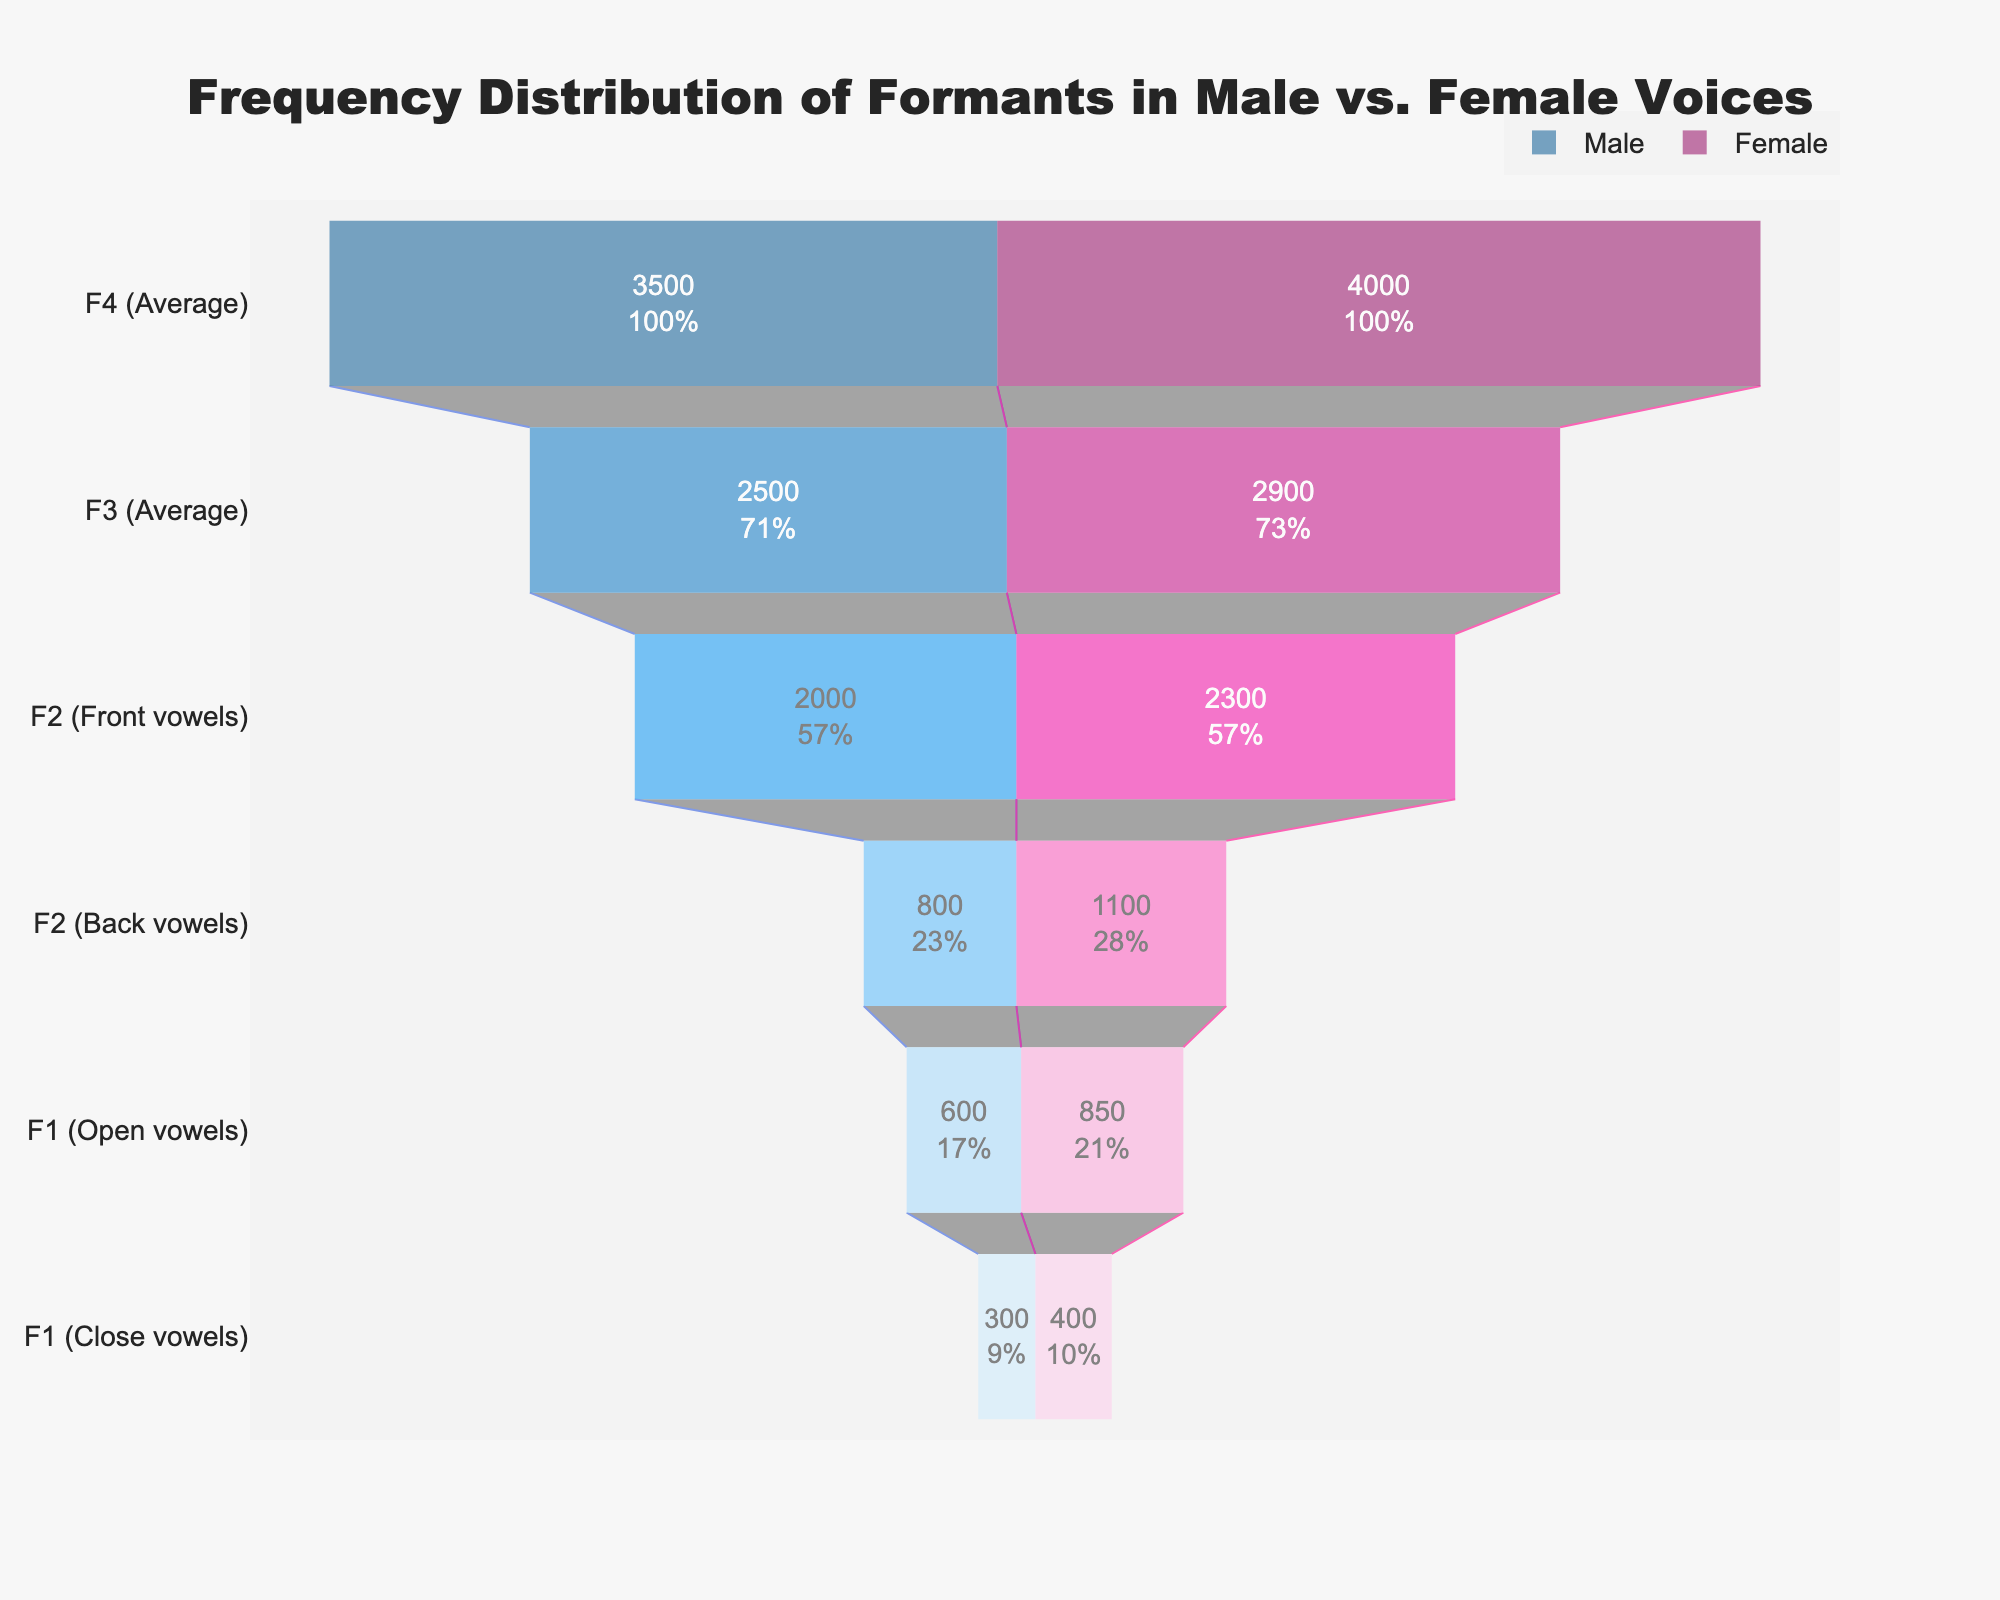What is the title of the funnel chart? The title of the funnel chart is displayed at the top center of the plot. It reads "Frequency Distribution of Formants in Male vs. Female Voices."
Answer: Frequency Distribution of Formants in Male vs. Female Voices What are the formants with the highest frequency for male and female voices, respectively? By examining the chart, the largest sections (highest frequencies) are at the top. For both male and female voices, the formants with the highest frequency are F4 (Average) with values 3500 Hz for males and 4000 Hz for females.
Answer: F4 (Average) for both Which formant shows the smallest difference in frequency between male and female voices? From the data values on the funnel chart, we calculate the differences between male and female frequencies for each formant. The smallest difference is for F3 (Average) with male frequency 2500 Hz and female frequency 2900 Hz, making the difference 400 Hz.
Answer: F3 (Average) What percentage of the initial value does the F2 (Back vowels) formant retain for both male and female voices? For F2 (Back vowels), the initial male frequency is 3500 Hz and its current value is 800 Hz, so the percentage retained is (800/3500) * 100%. For females, the initial frequency is 4000 Hz and the value is 1100 Hz, giving (1100/4000) * 100%. Calculating these, we get approximately 22.86% for males and 27.5% for females.
Answer: Approximately 22.86% for males and 27.5% for females How do the formant frequencies for F1 (Open vowels) compare between male and female voices? By looking at the funnel chart, we see that for F1 (Open vowels), the male frequency is 600 Hz and the female frequency is 850 Hz. Therefore, the female frequency is higher by 250 Hz.
Answer: Female frequency is higher by 250 Hz Which gender has a higher average frequency for F2 (Front vowels)? The value for F2 (Front vowels) in the funnel chart shows 2000 Hz for males and 2300 Hz for females. Comparing these, females have a higher average frequency by 300 Hz.
Answer: Female What is the sum of the frequencies for the F3 (Average) and F4 (Average) formants in male voices? Add the frequencies for F3 and F4 in males, which are 2500 Hz and 3500 Hz respectively. The sum is 2500 + 3500 = 6000 Hz.
Answer: 6000 Hz What is the formant with the lowest frequency for female voices? The funnel chart shows the sections from highest to lowest frequencies. The lowest frequency for female voices is F1 (Close vowels) with 400 Hz.
Answer: F1 (Close vowels) How many formants are displayed in the chart for each gender? Count the number of distinct formants listed on the funnel chart. There are 6 formants: F1 (Open vowels), F1 (Close vowels), F2 (Front vowels), F2 (Back vowels), F3 (Average), and F4 (Average).
Answer: 6 Which formant shows the largest percentage drop from F4 to F3 for both genders, and what are these percentages? For males: The percentage drop from F4 (3500 Hz) to F3 (2500 Hz) is ((3500 - 2500) / 3500) * 100% = 28.57%. For females: The percentage drop from F4 (4000 Hz) to F3 (2900 Hz) is ((4000 - 2900) / 4000) * 100% = 27.5%. Comparatively, the male percentage drop from F4 to F3 (28.57%) is larger than the female percentage drop (27.5%).
Answer: Male: 28.57%, Female: 27.5% 